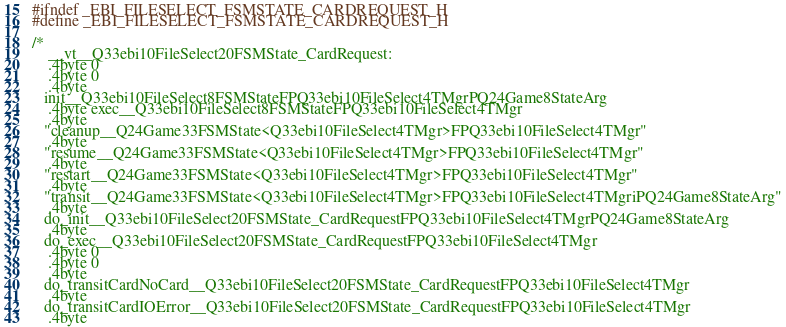<code> <loc_0><loc_0><loc_500><loc_500><_C_>#ifndef _EBI_FILESELECT_FSMSTATE_CARDREQUEST_H
#define _EBI_FILESELECT_FSMSTATE_CARDREQUEST_H

/*
    __vt__Q33ebi10FileSelect20FSMState_CardRequest:
    .4byte 0
    .4byte 0
    .4byte
   init__Q33ebi10FileSelect8FSMStateFPQ33ebi10FileSelect4TMgrPQ24Game8StateArg
    .4byte exec__Q33ebi10FileSelect8FSMStateFPQ33ebi10FileSelect4TMgr
    .4byte
   "cleanup__Q24Game33FSMState<Q33ebi10FileSelect4TMgr>FPQ33ebi10FileSelect4TMgr"
    .4byte
   "resume__Q24Game33FSMState<Q33ebi10FileSelect4TMgr>FPQ33ebi10FileSelect4TMgr"
    .4byte
   "restart__Q24Game33FSMState<Q33ebi10FileSelect4TMgr>FPQ33ebi10FileSelect4TMgr"
    .4byte
   "transit__Q24Game33FSMState<Q33ebi10FileSelect4TMgr>FPQ33ebi10FileSelect4TMgriPQ24Game8StateArg"
    .4byte
   do_init__Q33ebi10FileSelect20FSMState_CardRequestFPQ33ebi10FileSelect4TMgrPQ24Game8StateArg
    .4byte
   do_exec__Q33ebi10FileSelect20FSMState_CardRequestFPQ33ebi10FileSelect4TMgr
    .4byte 0
    .4byte 0
    .4byte
   do_transitCardNoCard__Q33ebi10FileSelect20FSMState_CardRequestFPQ33ebi10FileSelect4TMgr
    .4byte
   do_transitCardIOError__Q33ebi10FileSelect20FSMState_CardRequestFPQ33ebi10FileSelect4TMgr
    .4byte</code> 